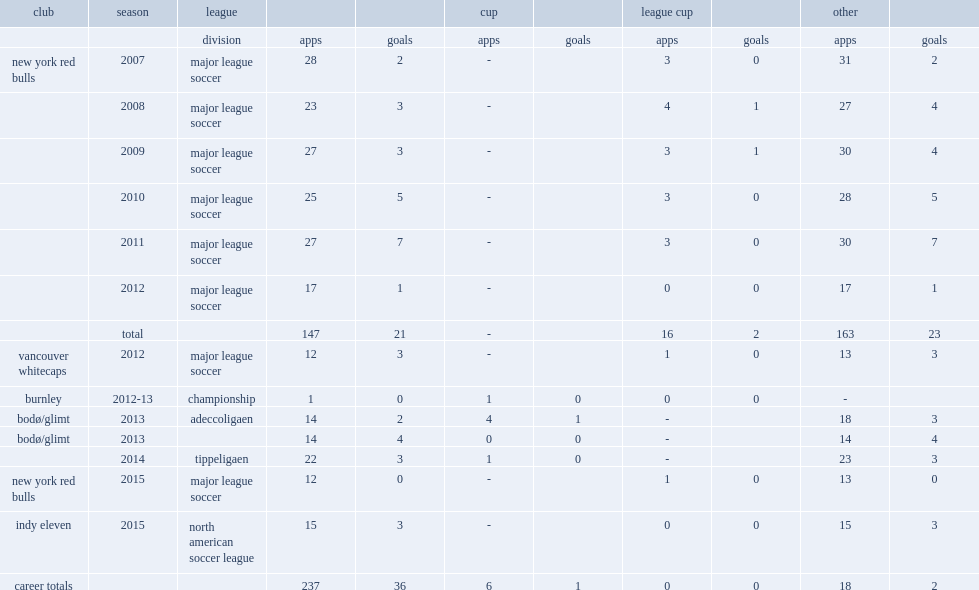Which league was richards loaned to in 2013? Adeccoligaen. 